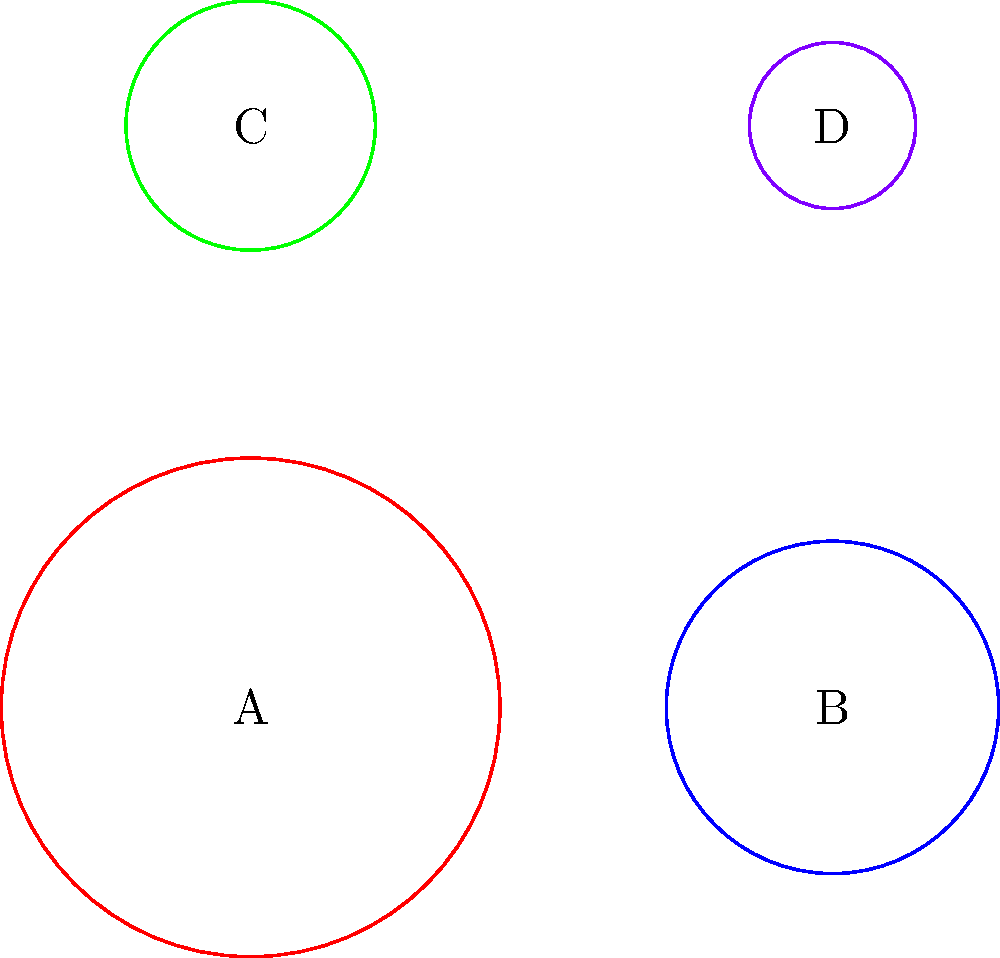In the aerial view diagram above, four religious gatherings are represented by circles A, B, C, and D. If the area of each circle is proportional to the number of attendees, rank the gatherings from largest to smallest in terms of attendance. To rank the gatherings from largest to smallest, we need to compare the areas of the circles. The area of a circle is proportional to the square of its radius. Let's follow these steps:

1. Observe the relative sizes of the circles:
   Circle A (red) appears largest
   Circle B (blue) appears second largest
   Circle C (green) appears third largest
   Circle D (purple) appears smallest

2. Compare the radii:
   A: r = 3
   B: r = 2
   C: r = 1.5
   D: r = 1

3. Calculate the relative areas (proportional to $r^2$):
   A: $3^2 = 9$
   B: $2^2 = 4$
   C: $1.5^2 = 2.25$
   D: $1^2 = 1$

4. Rank the gatherings based on these calculated areas:
   A (9) > B (4) > C (2.25) > D (1)

Therefore, the ranking from largest to smallest attendance is A, B, C, D.
Answer: A > B > C > D 